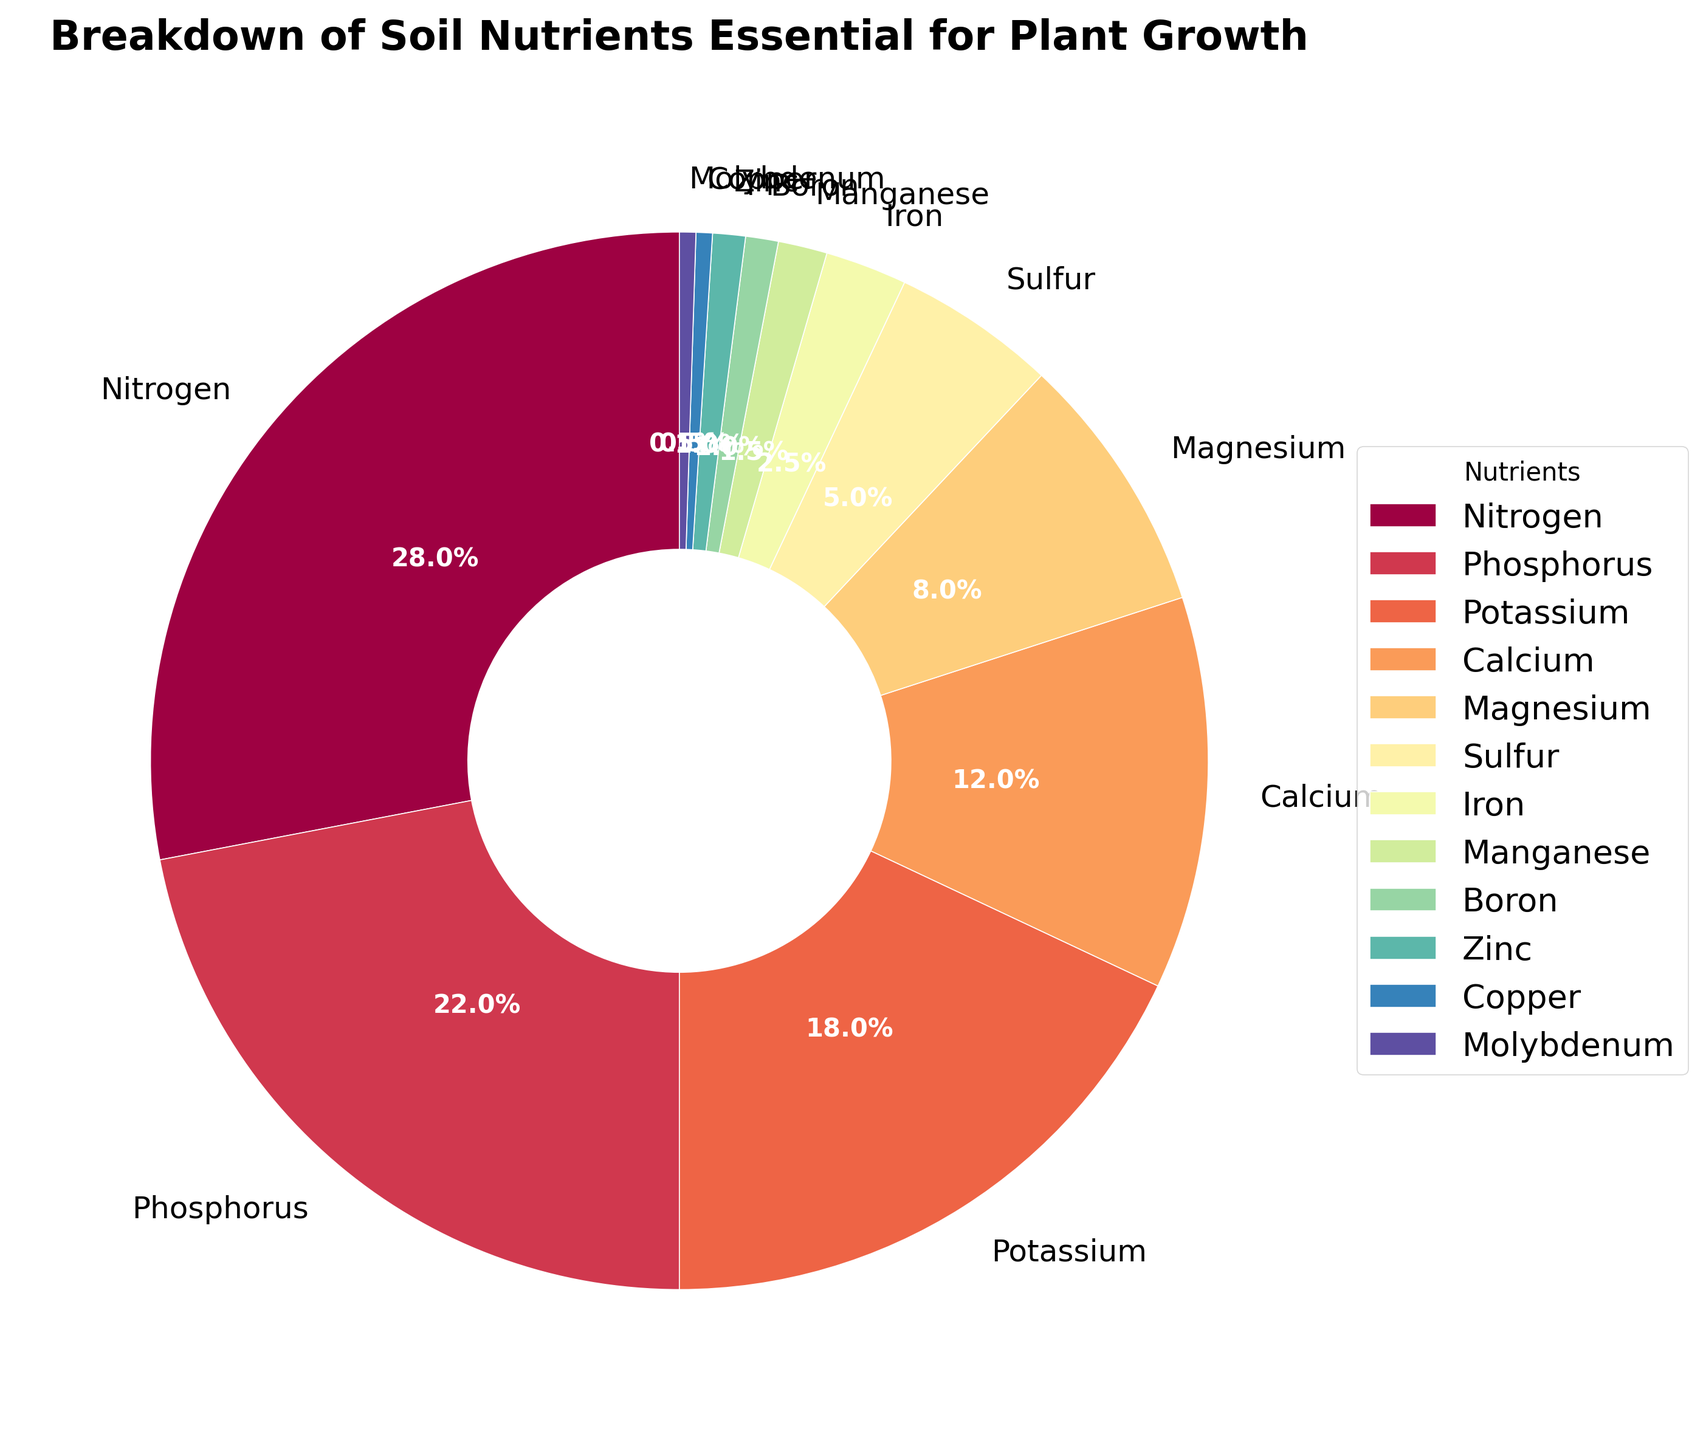Which nutrient takes up the largest percentage of the pie chart? The largest wedge in the pie chart represents Nitrogen. By visually inspecting the slices, Nitrogen has the biggest area, making it the largest percentage.
Answer: Nitrogen What is the combined percentage of Nitrogen and Phosphorus? Nitrogen is 28% and Phosphorus is 22%. Adding these together gives 28 + 22 = 50%.
Answer: 50% Which nutrient has a lesser percentage, Calcium or Magnesium? By comparing the wedges representing Calcium and Magnesium, Magnesium has a smaller slice.
Answer: Magnesium What is the percentage difference between Potassium and Calcium? Potassium is 18% and Calcium is 12%. The difference is calculated as 18 - 12 = 6%.
Answer: 6% Are there more nutrients with a percentage below 5% or above 5%? From the figure, nutrients below 5% are Sulfur, Iron, Manganese, Boron, Zinc, Copper, and Molybdenum, which makes 7 nutrients. Nutrients above 5% are Nitrogen, Phosphorus, Potassium, Calcium, and Magnesium, which amounts to 5 nutrients. Hence, there are more nutrients below 5%.
Answer: Below 5% What is the total percentage of nutrients with percentages less than 10%? Sum percentages of Magnesium (8%), Sulfur (5%), Iron (2.5%), Manganese (1.5%), Boron (1%), Zinc (1%), Copper (0.5%), and Molybdenum (0.5%). The total is 8 + 5 + 2.5 + 1.5 + 1 + 1 + 0.5 + 0.5 = 20%.
Answer: 20% How does the percentage of Iron compare to that of Zinc? The wedge representing Iron has a percentage of 2.5%, while Zinc has 1%. Therefore, Iron's percentage is greater than Zinc's percentage.
Answer: Greater than What is the average percentage of Nitrogen, Phosphorus, and Potassium? Sum the percentages of Nitrogen (28%), Phosphorus (22%), and Potassium (18%), then divide by 3. The calculation is (28 + 22 + 18)/3 = 68/3 ≈ 22.67%.
Answer: 22.67% Which nutrient slices are visually similar in size? The slices representing Boron and Zinc both reflect 1% each, appearing quite similar in size on the pie chart.
Answer: Boron and Zinc 